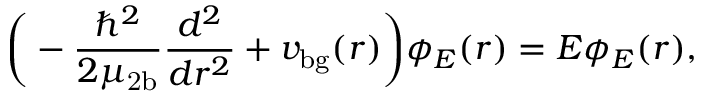<formula> <loc_0><loc_0><loc_500><loc_500>\left ( - \frac { \hbar { ^ } { 2 } } { 2 \mu _ { 2 b } } \frac { d ^ { 2 } } { d r ^ { 2 } } + v _ { b g } ( r ) \right ) \phi _ { E } ( r ) = E \phi _ { E } ( r ) ,</formula> 